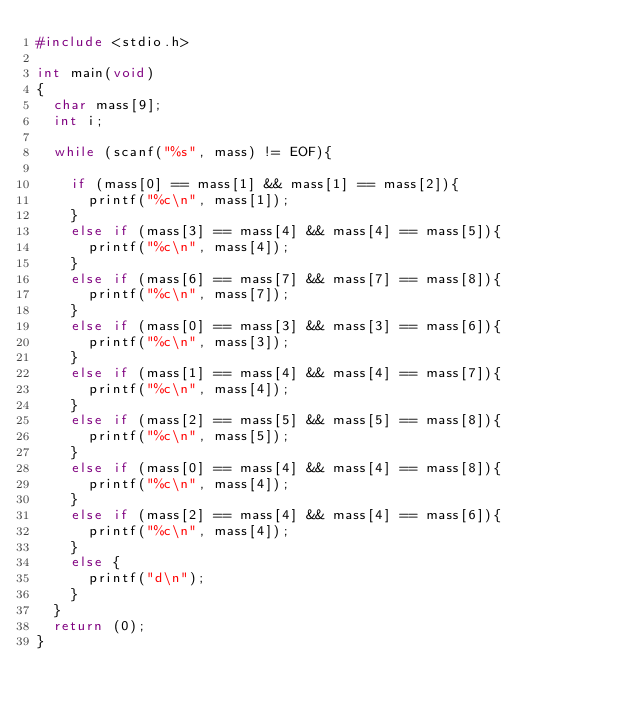<code> <loc_0><loc_0><loc_500><loc_500><_C_>#include <stdio.h>

int main(void)
{
	char mass[9];
	int i;
	
	while (scanf("%s", mass) != EOF){
	
		if (mass[0] == mass[1] && mass[1] == mass[2]){
			printf("%c\n", mass[1]);
		}
		else if (mass[3] == mass[4] && mass[4] == mass[5]){
			printf("%c\n", mass[4]);
		}
		else if (mass[6] == mass[7] && mass[7] == mass[8]){
			printf("%c\n", mass[7]);
		}
		else if (mass[0] == mass[3] && mass[3] == mass[6]){
			printf("%c\n", mass[3]);
		}
		else if (mass[1] == mass[4] && mass[4] == mass[7]){
			printf("%c\n", mass[4]);
		}
		else if (mass[2] == mass[5] && mass[5] == mass[8]){
			printf("%c\n", mass[5]);
		}
		else if (mass[0] == mass[4] && mass[4] == mass[8]){
			printf("%c\n", mass[4]);
		}
		else if (mass[2] == mass[4] && mass[4] == mass[6]){
			printf("%c\n", mass[4]);
		}
		else {
			printf("d\n");
		}
	}
	return (0);
}</code> 